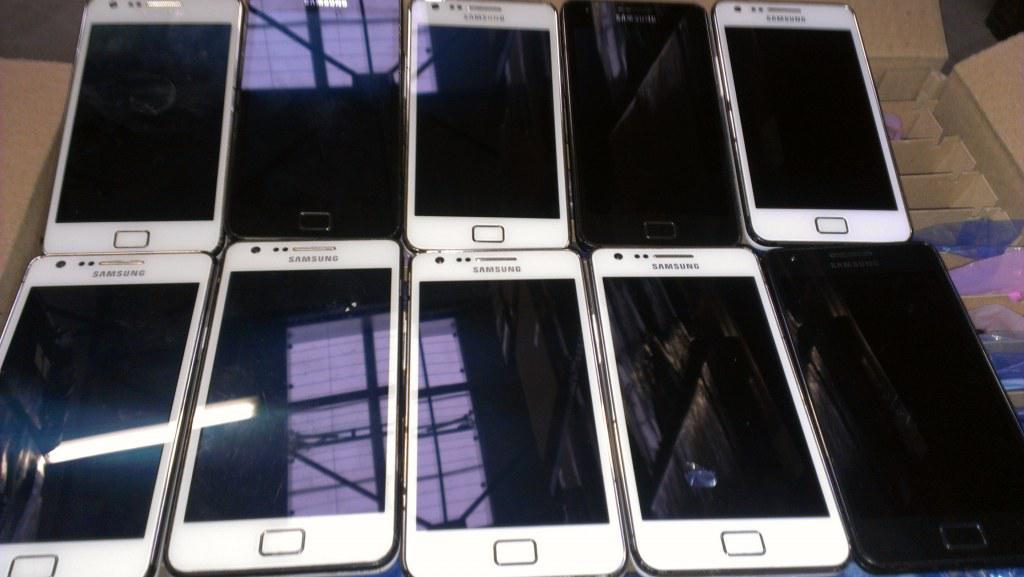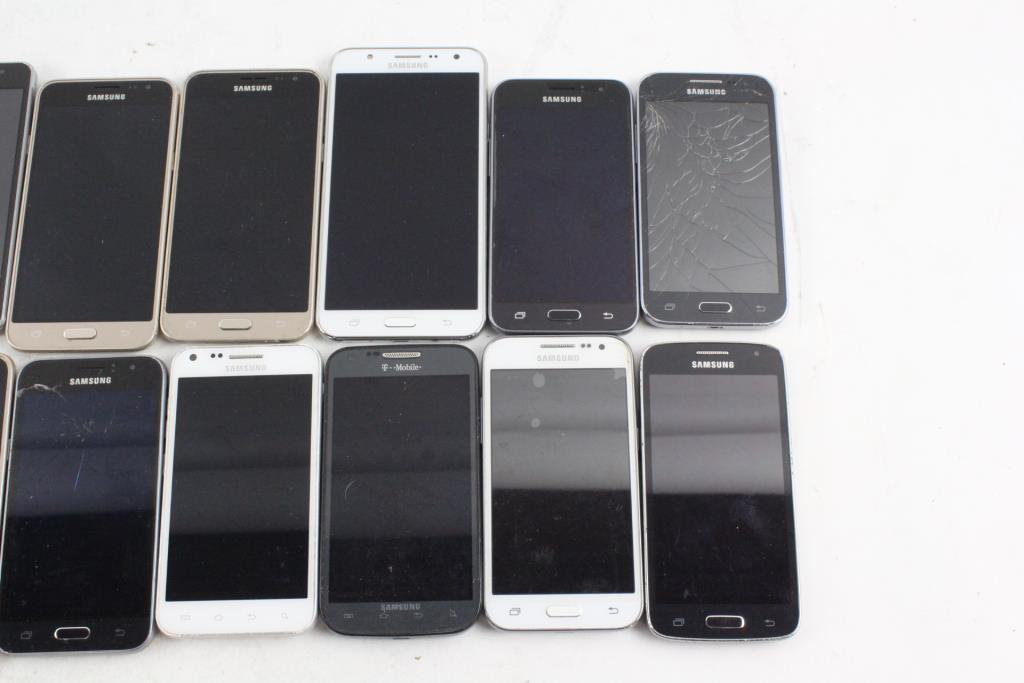The first image is the image on the left, the second image is the image on the right. Evaluate the accuracy of this statement regarding the images: "The right image contains two horizontal rows of cell phones.". Is it true? Answer yes or no. Yes. The first image is the image on the left, the second image is the image on the right. Assess this claim about the two images: "Cell phones are lined in two lines on a surface in the image on the right.". Correct or not? Answer yes or no. Yes. 